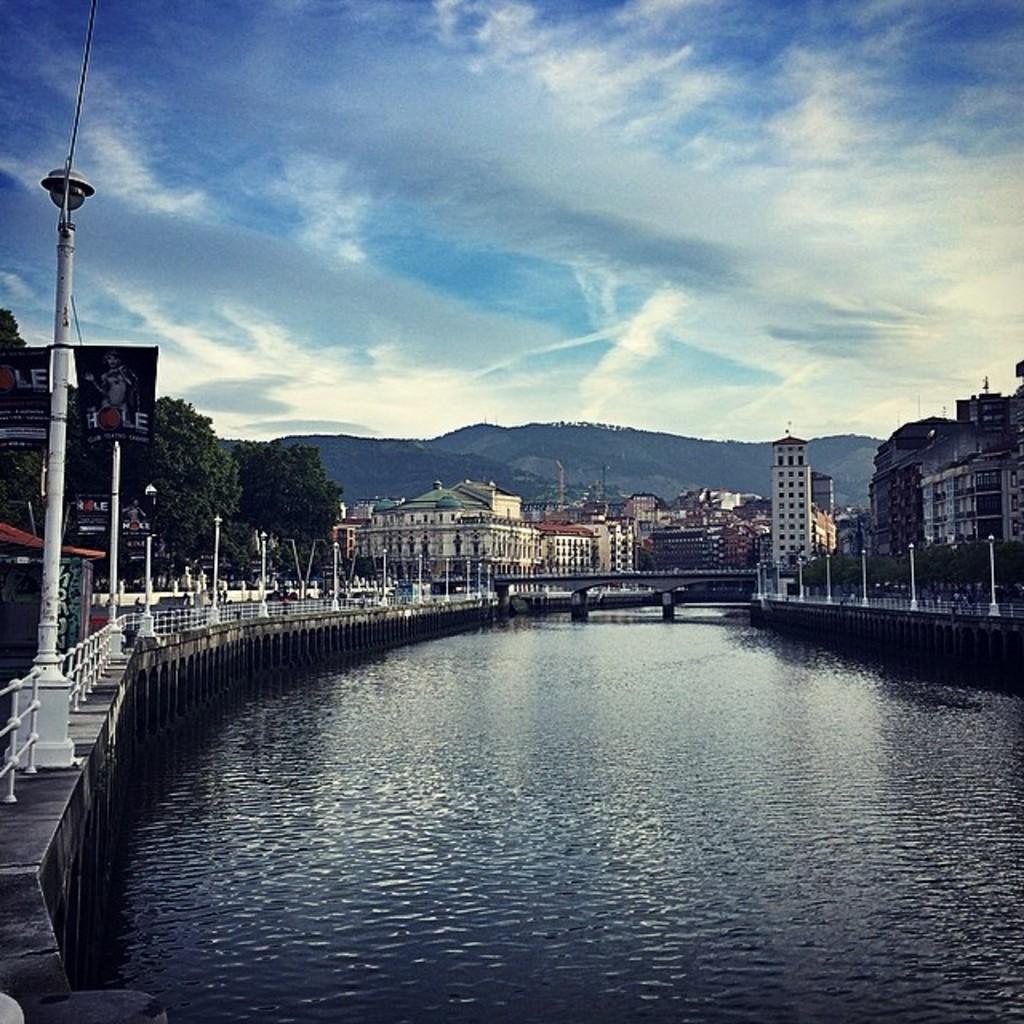Can you describe this image briefly? Here in this picture, in the middle we can see water present all over there and we can also see a bridge present in the far over there and on the either side we can see a railing present and we can also see lamp posts, buildings, plants and trees all over there and in the far we can see mountains covered with grass and plants present over there and we can see the sky is fully covered with clouds over there. 